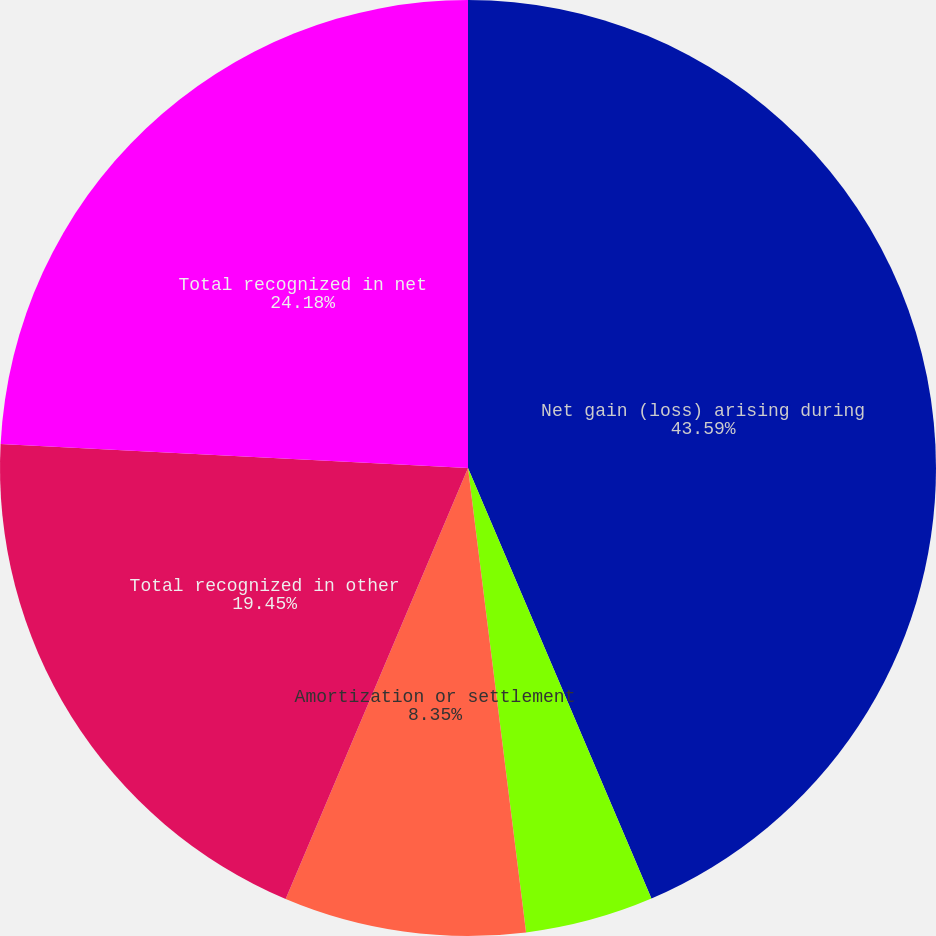<chart> <loc_0><loc_0><loc_500><loc_500><pie_chart><fcel>Net gain (loss) arising during<fcel>Amortization or curtailment<fcel>Amortization or settlement<fcel>Total recognized in other<fcel>Total recognized in net<nl><fcel>43.59%<fcel>4.43%<fcel>8.35%<fcel>19.45%<fcel>24.18%<nl></chart> 